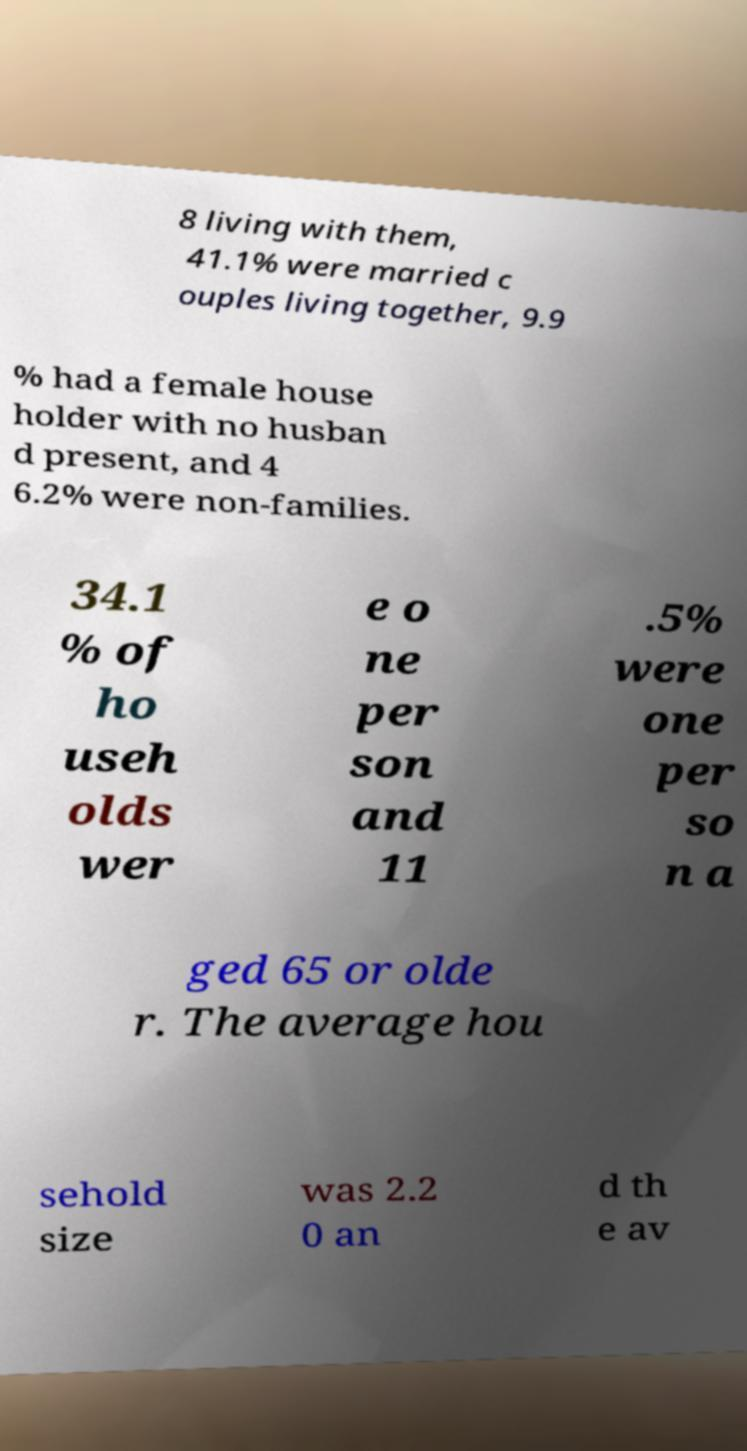Can you read and provide the text displayed in the image?This photo seems to have some interesting text. Can you extract and type it out for me? 8 living with them, 41.1% were married c ouples living together, 9.9 % had a female house holder with no husban d present, and 4 6.2% were non-families. 34.1 % of ho useh olds wer e o ne per son and 11 .5% were one per so n a ged 65 or olde r. The average hou sehold size was 2.2 0 an d th e av 